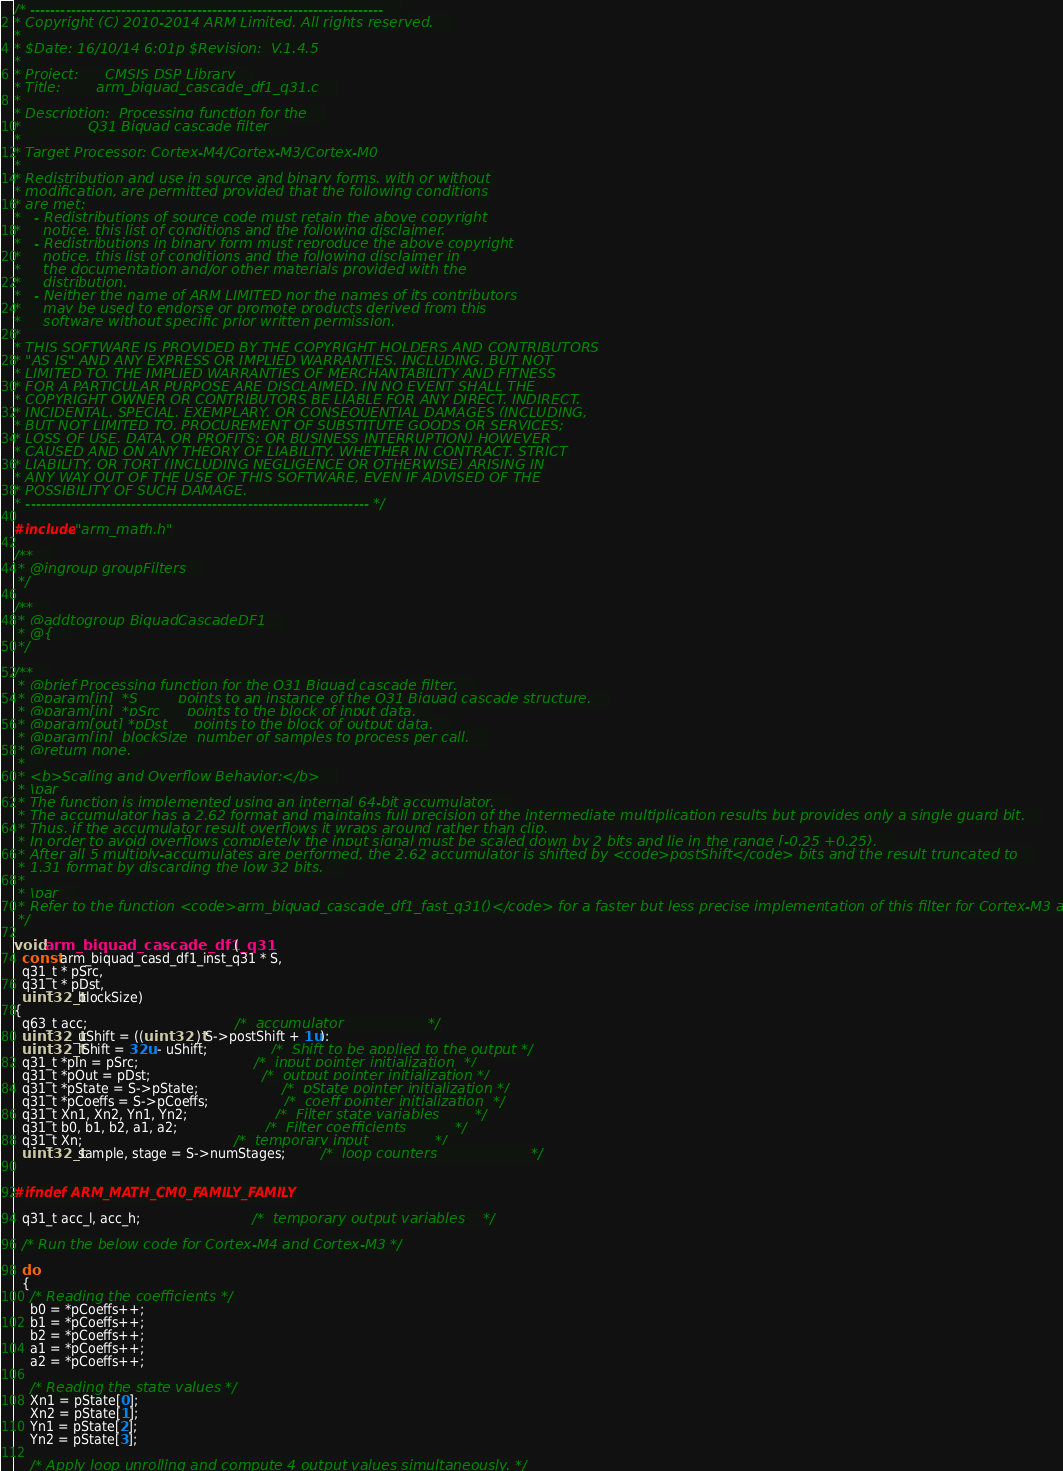Convert code to text. <code><loc_0><loc_0><loc_500><loc_500><_C_>/* ----------------------------------------------------------------------    
* Copyright (C) 2010-2014 ARM Limited. All rights reserved.    
*    
* $Date: 16/10/14 6:01p $Revision: 	V.1.4.5
*    
* Project: 	    CMSIS DSP Library    
* Title:	    arm_biquad_cascade_df1_q31.c    
*    
* Description:	Processing function for the    
*				Q31 Biquad cascade filter    
*    
* Target Processor: Cortex-M4/Cortex-M3/Cortex-M0
*  
* Redistribution and use in source and binary forms, with or without 
* modification, are permitted provided that the following conditions
* are met:
*   - Redistributions of source code must retain the above copyright
*     notice, this list of conditions and the following disclaimer.
*   - Redistributions in binary form must reproduce the above copyright
*     notice, this list of conditions and the following disclaimer in
*     the documentation and/or other materials provided with the 
*     distribution.
*   - Neither the name of ARM LIMITED nor the names of its contributors
*     may be used to endorse or promote products derived from this
*     software without specific prior written permission.
*
* THIS SOFTWARE IS PROVIDED BY THE COPYRIGHT HOLDERS AND CONTRIBUTORS
* "AS IS" AND ANY EXPRESS OR IMPLIED WARRANTIES, INCLUDING, BUT NOT
* LIMITED TO, THE IMPLIED WARRANTIES OF MERCHANTABILITY AND FITNESS
* FOR A PARTICULAR PURPOSE ARE DISCLAIMED. IN NO EVENT SHALL THE 
* COPYRIGHT OWNER OR CONTRIBUTORS BE LIABLE FOR ANY DIRECT, INDIRECT,
* INCIDENTAL, SPECIAL, EXEMPLARY, OR CONSEQUENTIAL DAMAGES (INCLUDING,
* BUT NOT LIMITED TO, PROCUREMENT OF SUBSTITUTE GOODS OR SERVICES;
* LOSS OF USE, DATA, OR PROFITS; OR BUSINESS INTERRUPTION) HOWEVER
* CAUSED AND ON ANY THEORY OF LIABILITY, WHETHER IN CONTRACT, STRICT
* LIABILITY, OR TORT (INCLUDING NEGLIGENCE OR OTHERWISE) ARISING IN
* ANY WAY OUT OF THE USE OF THIS SOFTWARE, EVEN IF ADVISED OF THE
* POSSIBILITY OF SUCH DAMAGE.     
* -------------------------------------------------------------------- */

#include "arm_math.h"

/**    
 * @ingroup groupFilters    
 */

/**    
 * @addtogroup BiquadCascadeDF1    
 * @{    
 */

/**    
 * @brief Processing function for the Q31 Biquad cascade filter.    
 * @param[in]  *S         points to an instance of the Q31 Biquad cascade structure.    
 * @param[in]  *pSrc      points to the block of input data.    
 * @param[out] *pDst      points to the block of output data.    
 * @param[in]  blockSize  number of samples to process per call.    
 * @return none.    
 *    
 * <b>Scaling and Overflow Behavior:</b>    
 * \par    
 * The function is implemented using an internal 64-bit accumulator.    
 * The accumulator has a 2.62 format and maintains full precision of the intermediate multiplication results but provides only a single guard bit.    
 * Thus, if the accumulator result overflows it wraps around rather than clip.    
 * In order to avoid overflows completely the input signal must be scaled down by 2 bits and lie in the range [-0.25 +0.25).    
 * After all 5 multiply-accumulates are performed, the 2.62 accumulator is shifted by <code>postShift</code> bits and the result truncated to    
 * 1.31 format by discarding the low 32 bits.    
 *    
 * \par    
 * Refer to the function <code>arm_biquad_cascade_df1_fast_q31()</code> for a faster but less precise implementation of this filter for Cortex-M3 and Cortex-M4.    
 */

void arm_biquad_cascade_df1_q31(
  const arm_biquad_casd_df1_inst_q31 * S,
  q31_t * pSrc,
  q31_t * pDst,
  uint32_t blockSize)
{
  q63_t acc;                                     /*  accumulator                   */
  uint32_t uShift = ((uint32_t) S->postShift + 1u);
  uint32_t lShift = 32u - uShift;                /*  Shift to be applied to the output */
  q31_t *pIn = pSrc;                             /*  input pointer initialization  */
  q31_t *pOut = pDst;                            /*  output pointer initialization */
  q31_t *pState = S->pState;                     /*  pState pointer initialization */
  q31_t *pCoeffs = S->pCoeffs;                   /*  coeff pointer initialization  */
  q31_t Xn1, Xn2, Yn1, Yn2;                      /*  Filter state variables        */
  q31_t b0, b1, b2, a1, a2;                      /*  Filter coefficients           */
  q31_t Xn;                                      /*  temporary input               */
  uint32_t sample, stage = S->numStages;         /*  loop counters                     */


#ifndef ARM_MATH_CM0_FAMILY_FAMILY

  q31_t acc_l, acc_h;                            /*  temporary output variables    */

  /* Run the below code for Cortex-M4 and Cortex-M3 */

  do
  {
    /* Reading the coefficients */
    b0 = *pCoeffs++;
    b1 = *pCoeffs++;
    b2 = *pCoeffs++;
    a1 = *pCoeffs++;
    a2 = *pCoeffs++;

    /* Reading the state values */
    Xn1 = pState[0];
    Xn2 = pState[1];
    Yn1 = pState[2];
    Yn2 = pState[3];

    /* Apply loop unrolling and compute 4 output values simultaneously. */</code> 